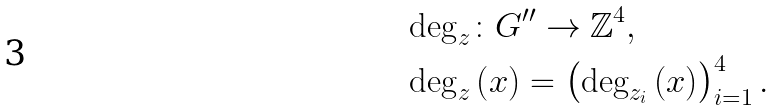Convert formula to latex. <formula><loc_0><loc_0><loc_500><loc_500>& \deg _ { z } \colon G ^ { \prime \prime } \rightarrow \mathbb { Z } ^ { 4 } , \\ & \deg _ { z } \left ( x \right ) = \left ( \deg _ { z _ { i } } \left ( x \right ) \right ) _ { i = 1 } ^ { 4 } .</formula> 